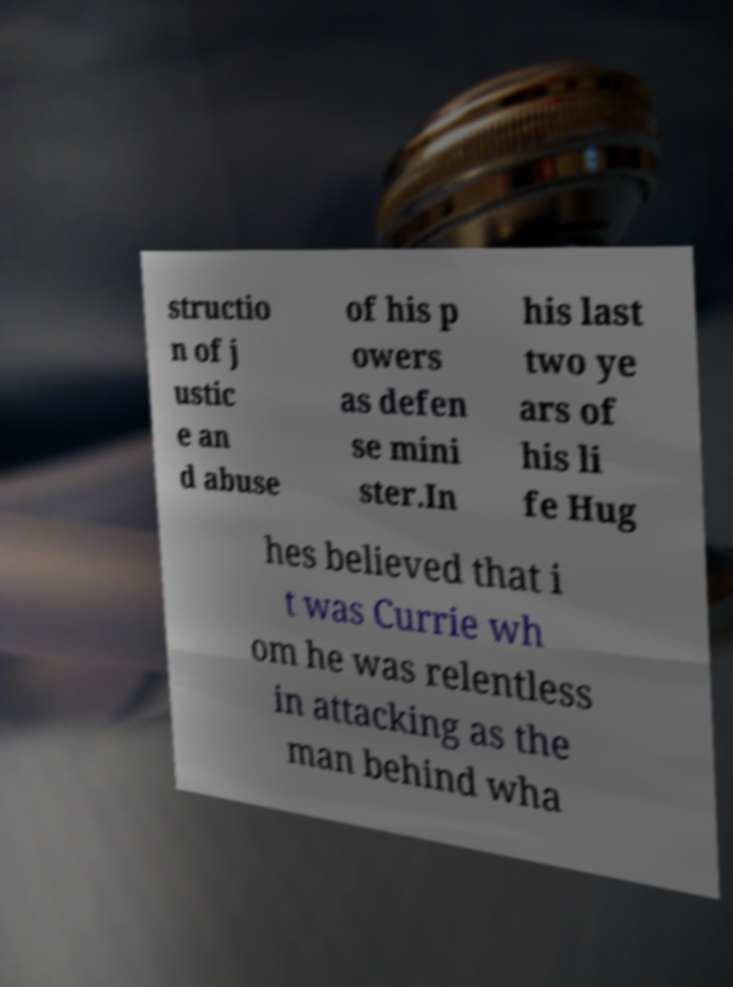There's text embedded in this image that I need extracted. Can you transcribe it verbatim? structio n of j ustic e an d abuse of his p owers as defen se mini ster.In his last two ye ars of his li fe Hug hes believed that i t was Currie wh om he was relentless in attacking as the man behind wha 